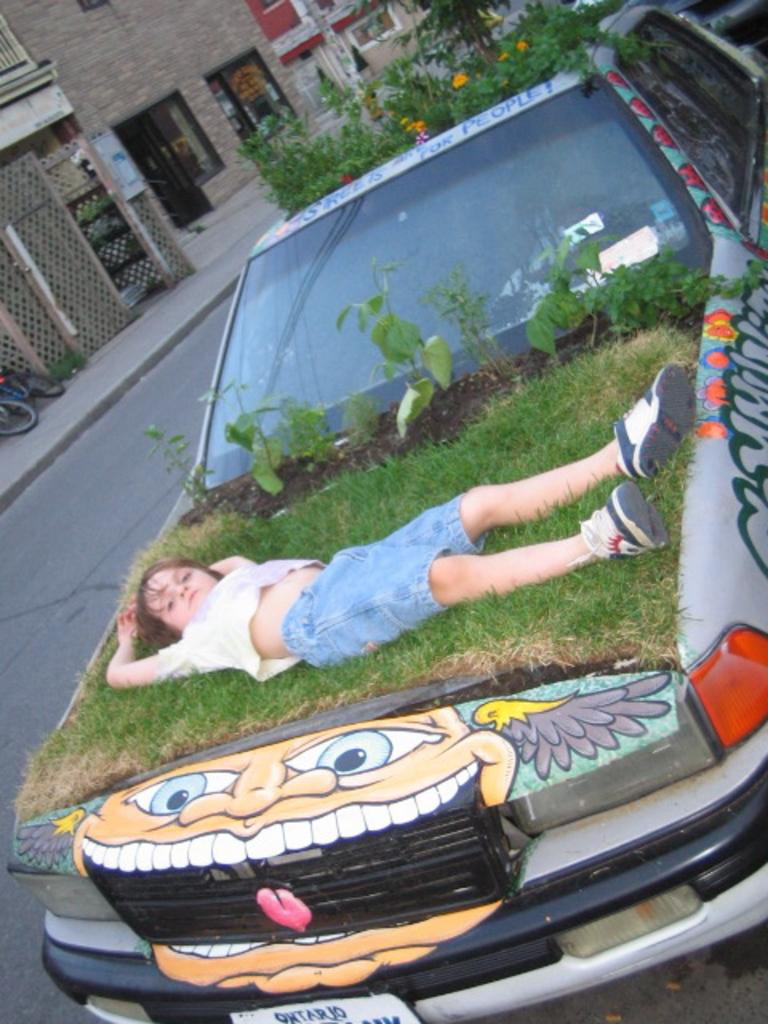What is the kid sitting on in the image? The kid is sitting on a grassy surface. Where is the grassy surface located? The grassy surface is on top of a car. What is the position of the car in the image? The car is in the middle of the image. What can be seen in the background of the image? There are buildings in the background of the image. How many ducks are swimming in the car's engine in the image? There are no ducks present in the image, and the car's engine is not visible. 